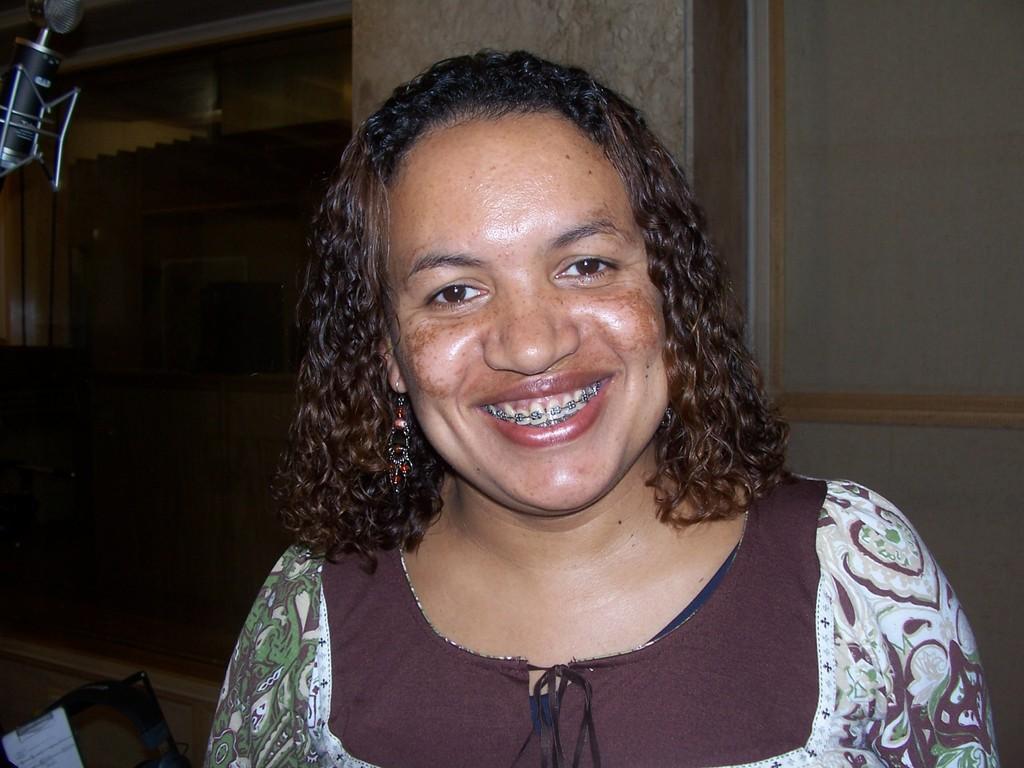Can you describe this image briefly? In this image we can a lady. There is an object at the left side of the image. There is an object at the bottom of the image. 